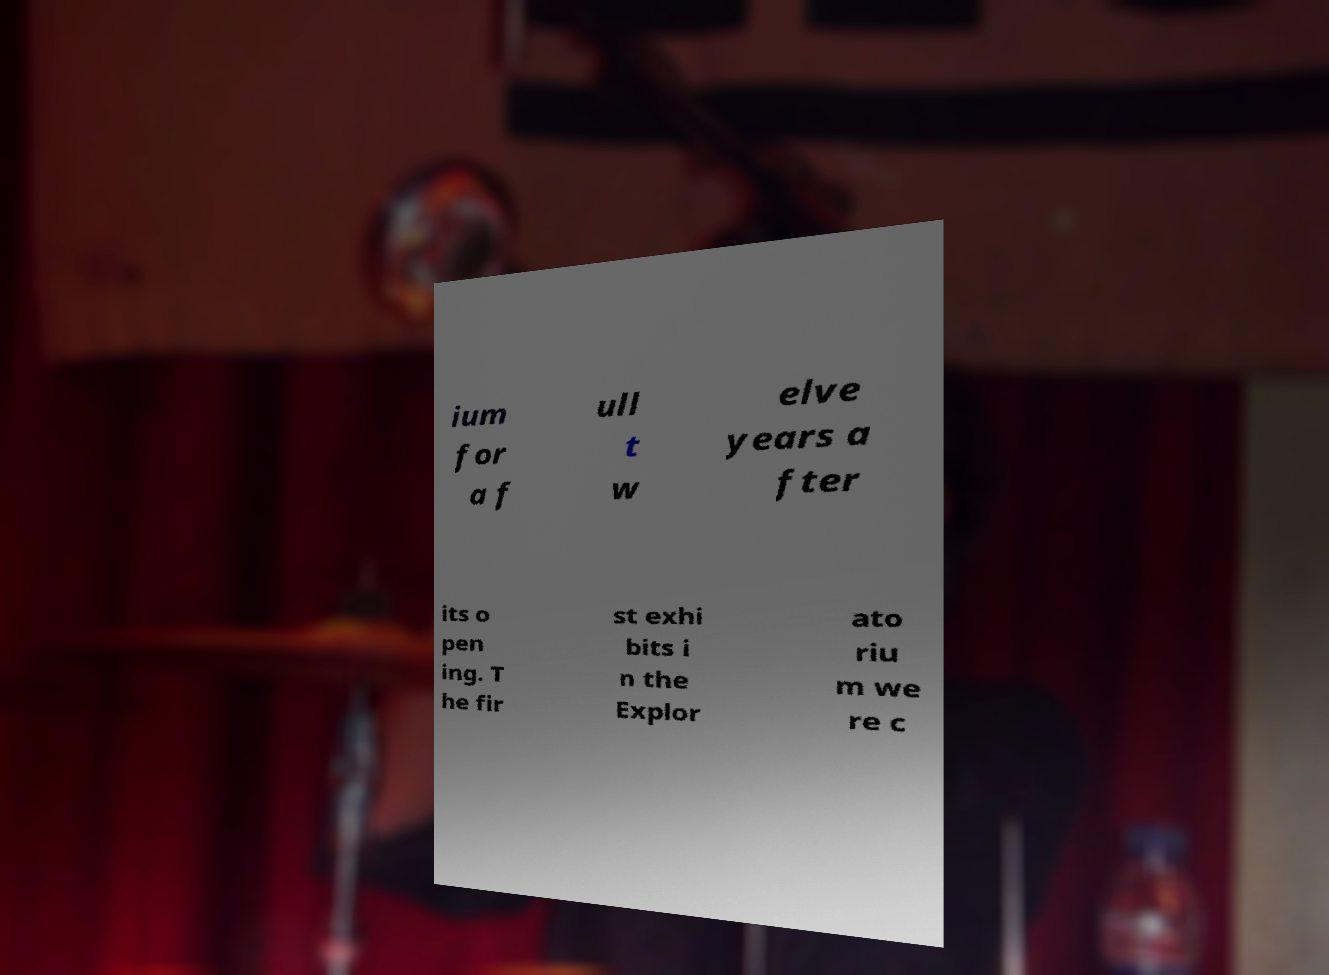There's text embedded in this image that I need extracted. Can you transcribe it verbatim? ium for a f ull t w elve years a fter its o pen ing. T he fir st exhi bits i n the Explor ato riu m we re c 